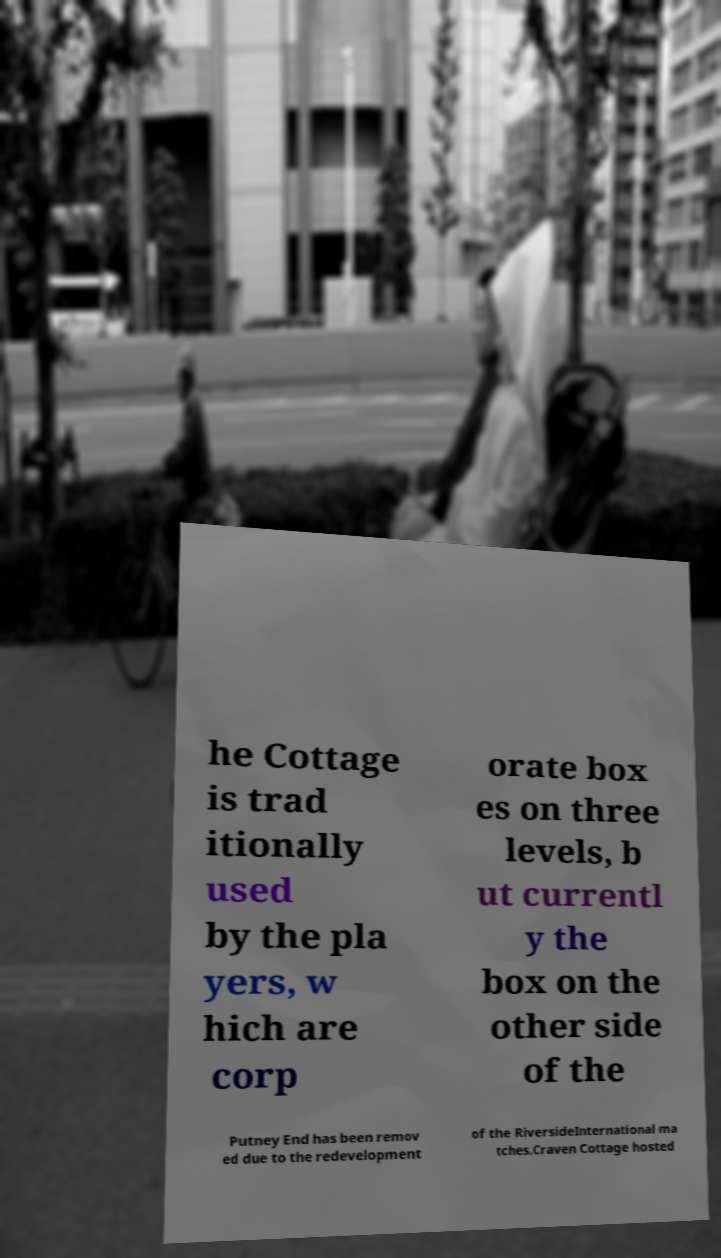There's text embedded in this image that I need extracted. Can you transcribe it verbatim? he Cottage is trad itionally used by the pla yers, w hich are corp orate box es on three levels, b ut currentl y the box on the other side of the Putney End has been remov ed due to the redevelopment of the RiversideInternational ma tches.Craven Cottage hosted 